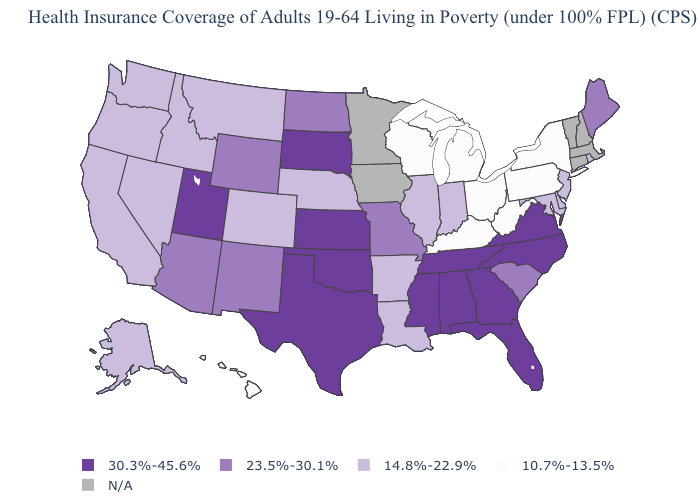What is the highest value in the USA?
Give a very brief answer. 30.3%-45.6%. Does New Mexico have the highest value in the USA?
Quick response, please. No. Name the states that have a value in the range 10.7%-13.5%?
Concise answer only. Hawaii, Kentucky, Michigan, New York, Ohio, Pennsylvania, West Virginia, Wisconsin. What is the value of Michigan?
Answer briefly. 10.7%-13.5%. What is the value of Kansas?
Be succinct. 30.3%-45.6%. Name the states that have a value in the range 10.7%-13.5%?
Answer briefly. Hawaii, Kentucky, Michigan, New York, Ohio, Pennsylvania, West Virginia, Wisconsin. Among the states that border Texas , which have the lowest value?
Be succinct. Arkansas, Louisiana. What is the highest value in states that border Connecticut?
Write a very short answer. 14.8%-22.9%. Name the states that have a value in the range 23.5%-30.1%?
Short answer required. Arizona, Maine, Missouri, New Mexico, North Dakota, South Carolina, Wyoming. Does Utah have the highest value in the West?
Be succinct. Yes. What is the lowest value in the USA?
Answer briefly. 10.7%-13.5%. Name the states that have a value in the range 30.3%-45.6%?
Quick response, please. Alabama, Florida, Georgia, Kansas, Mississippi, North Carolina, Oklahoma, South Dakota, Tennessee, Texas, Utah, Virginia. Among the states that border Virginia , which have the highest value?
Keep it brief. North Carolina, Tennessee. Which states have the lowest value in the MidWest?
Be succinct. Michigan, Ohio, Wisconsin. How many symbols are there in the legend?
Answer briefly. 5. 